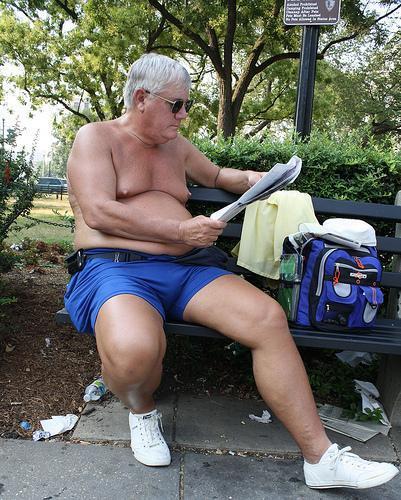How many light poles are behind him?
Give a very brief answer. 1. 